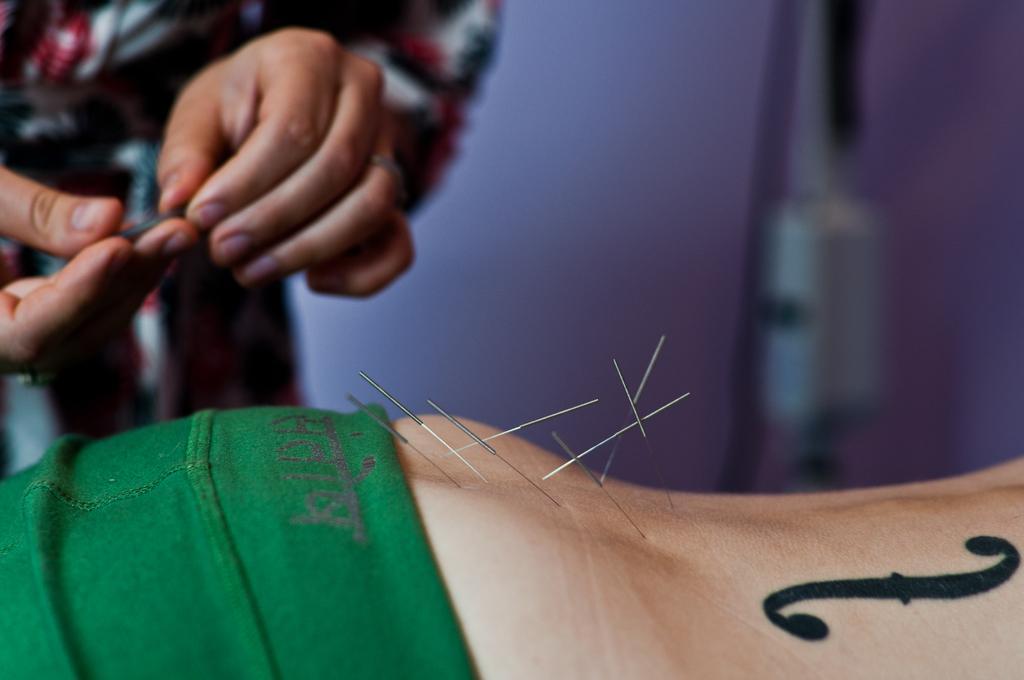Describe this image in one or two sentences. In this picture I can see a human standing and holding few needles in the hands and I can see few needles pierced into the other human body and I can see a wall in the background 